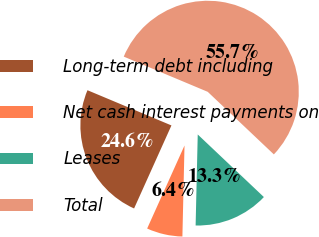Convert chart to OTSL. <chart><loc_0><loc_0><loc_500><loc_500><pie_chart><fcel>Long-term debt including<fcel>Net cash interest payments on<fcel>Leases<fcel>Total<nl><fcel>24.59%<fcel>6.36%<fcel>13.31%<fcel>55.74%<nl></chart> 